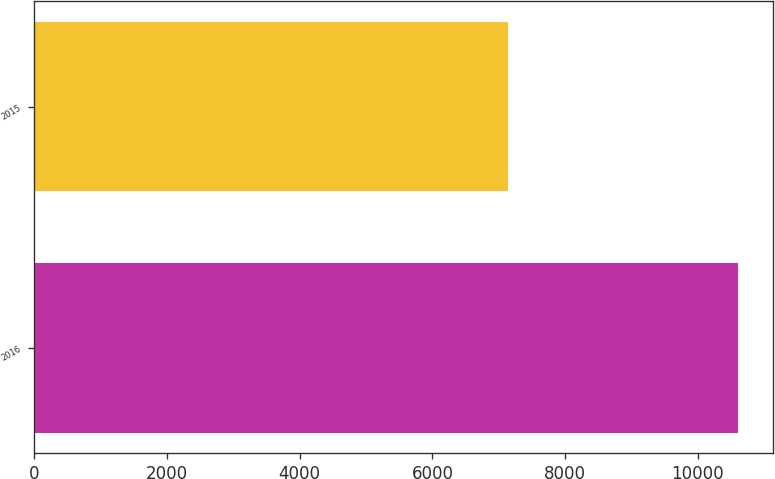Convert chart to OTSL. <chart><loc_0><loc_0><loc_500><loc_500><bar_chart><fcel>2016<fcel>2015<nl><fcel>10604<fcel>7144<nl></chart> 